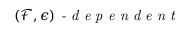<formula> <loc_0><loc_0><loc_500><loc_500>( \mathcal { F } , \epsilon ) - d e p e n d e n t</formula> 